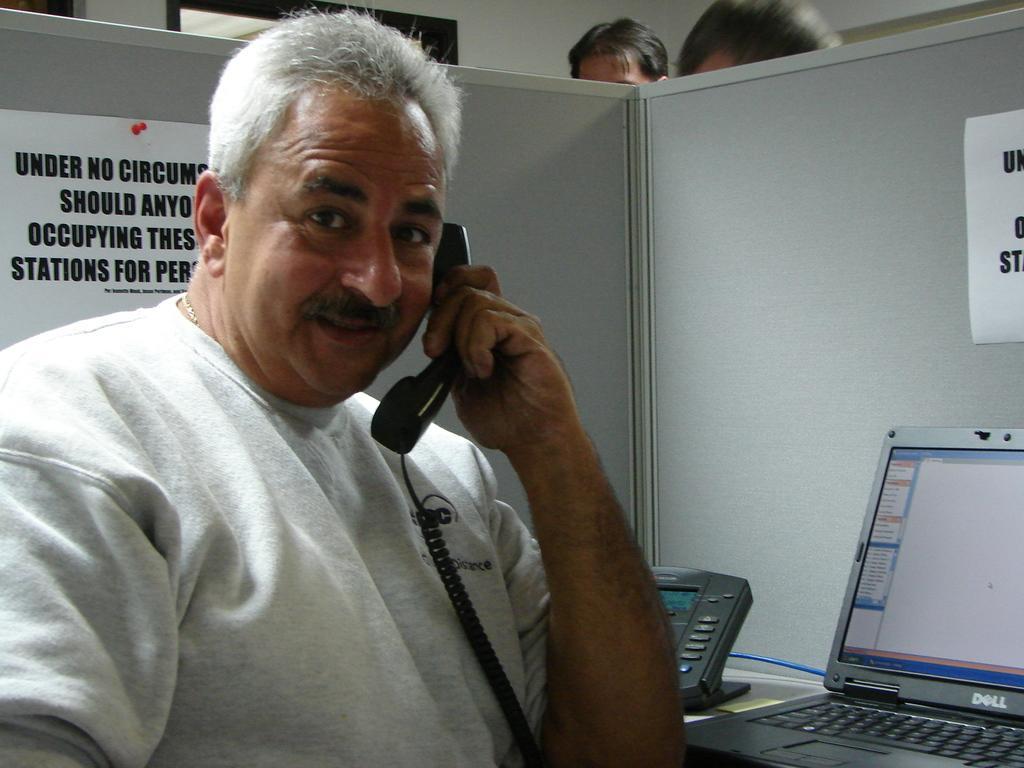Please provide a concise description of this image. In this image we can see three persons, one of them is holding a phone receiver, there is a telephone, laptop, some poster on the cabin with some text on it, also we can see the wall. 